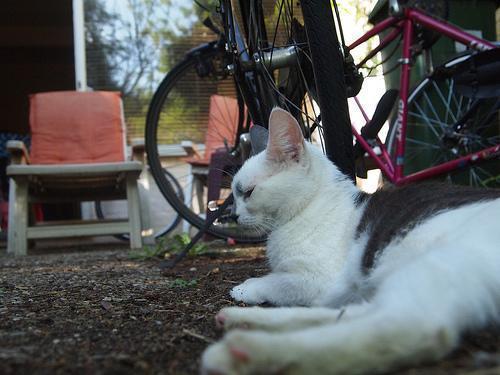How many bicycles are there?
Give a very brief answer. 2. 